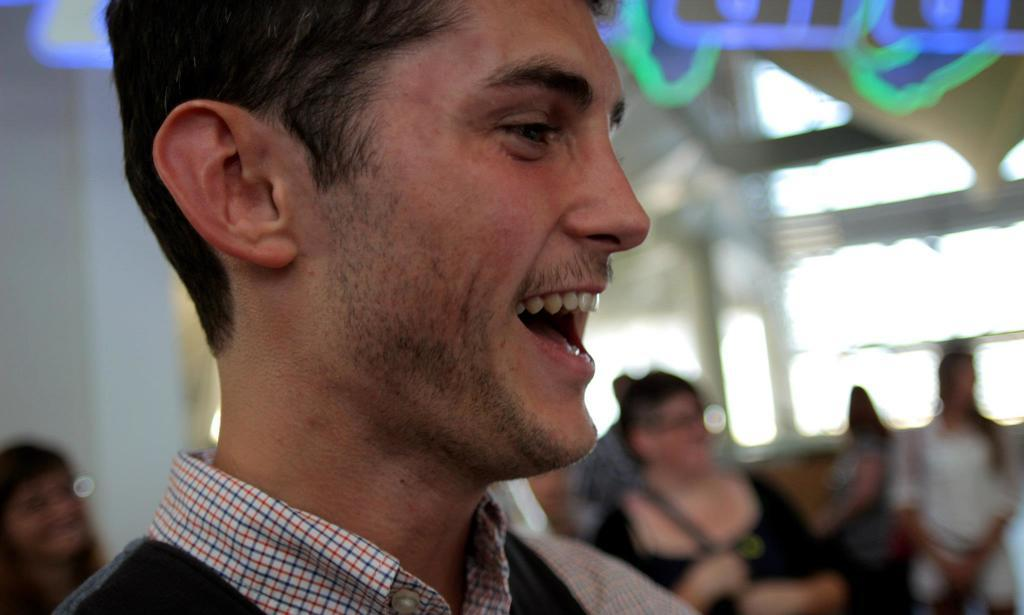Who is present in the image? There is a man in the image. What is the man doing in the image? The man is laughing. What can be seen in the background of the image? There are walls, windows, handles, and a crowd in the background of the image. What year is the snail depicted in the image? There is no snail present in the image, so it is not possible to determine the year it might be depicted. 